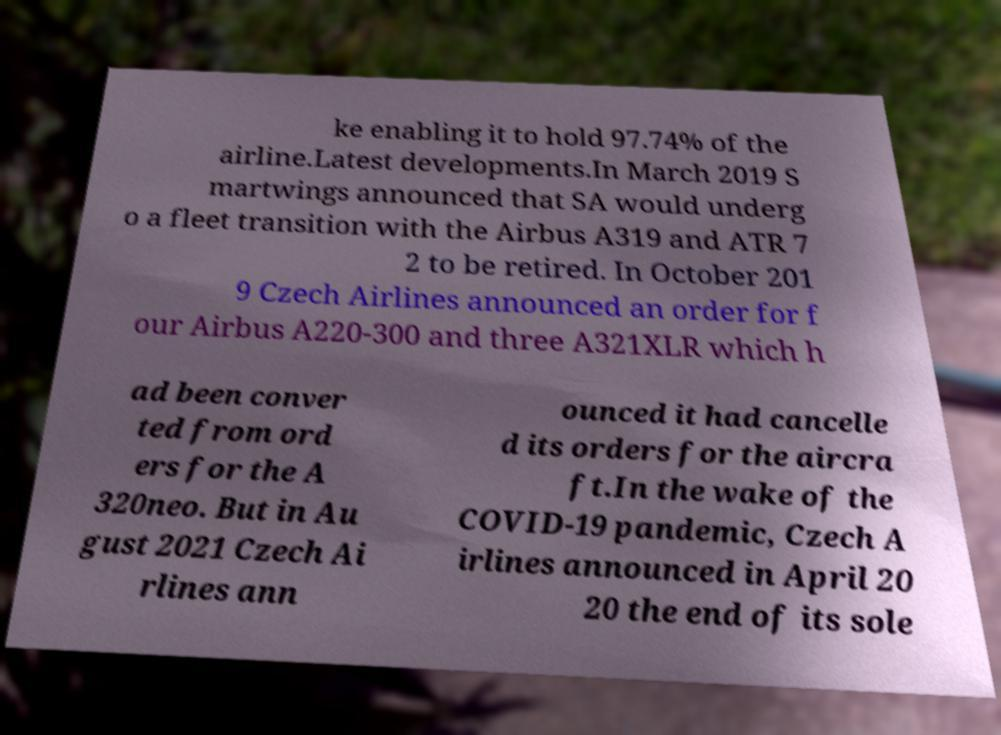Could you assist in decoding the text presented in this image and type it out clearly? ke enabling it to hold 97.74% of the airline.Latest developments.In March 2019 S martwings announced that SA would underg o a fleet transition with the Airbus A319 and ATR 7 2 to be retired. In October 201 9 Czech Airlines announced an order for f our Airbus A220-300 and three A321XLR which h ad been conver ted from ord ers for the A 320neo. But in Au gust 2021 Czech Ai rlines ann ounced it had cancelle d its orders for the aircra ft.In the wake of the COVID-19 pandemic, Czech A irlines announced in April 20 20 the end of its sole 